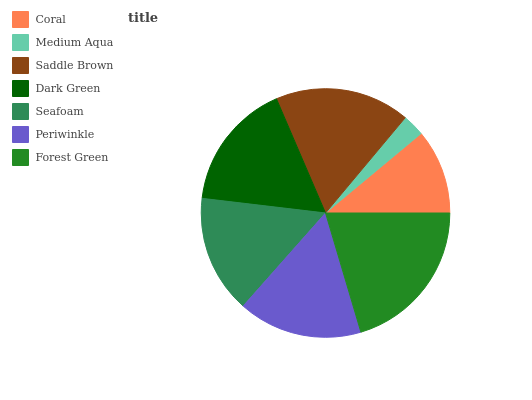Is Medium Aqua the minimum?
Answer yes or no. Yes. Is Forest Green the maximum?
Answer yes or no. Yes. Is Saddle Brown the minimum?
Answer yes or no. No. Is Saddle Brown the maximum?
Answer yes or no. No. Is Saddle Brown greater than Medium Aqua?
Answer yes or no. Yes. Is Medium Aqua less than Saddle Brown?
Answer yes or no. Yes. Is Medium Aqua greater than Saddle Brown?
Answer yes or no. No. Is Saddle Brown less than Medium Aqua?
Answer yes or no. No. Is Periwinkle the high median?
Answer yes or no. Yes. Is Periwinkle the low median?
Answer yes or no. Yes. Is Saddle Brown the high median?
Answer yes or no. No. Is Medium Aqua the low median?
Answer yes or no. No. 